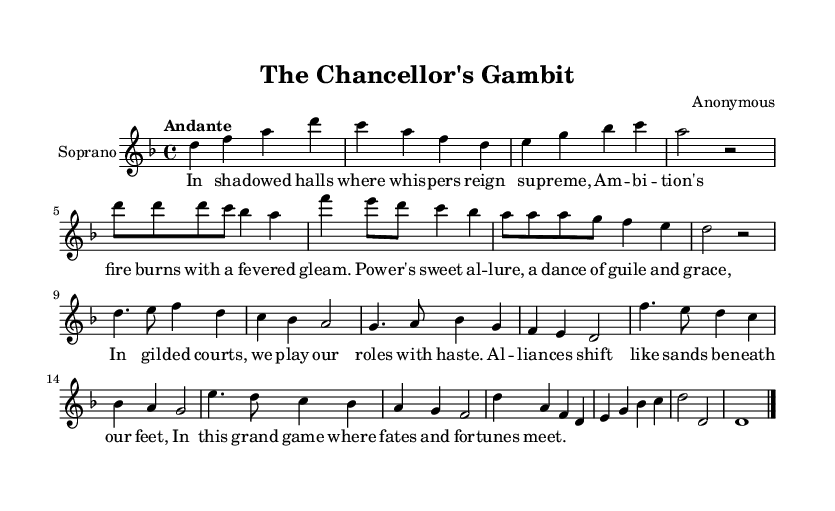What is the key signature of this music? The key signature is D minor, which is indicated by one flat (B flat). This is confirmed by looking at the clef and the beginning of the piece where the key signature is notated.
Answer: D minor What is the time signature of the piece? The time signature is 4/4, which indicates there are four beats in each measure and the quarter note receives one beat. This is shown at the beginning of the score.
Answer: 4/4 What is the tempo marking? The tempo marking is "Andante," which suggests a moderately slow tempo. This is specified in the measure at the beginning of the piece.
Answer: Andante What type of vocal part is featured in this score? The vocal part featured is a Soprano, as indicated by the label on the staff where the music is written.
Answer: Soprano How many measures are in the Aria section? The Aria section consists of 8 measures, which can be counted from the start of the section to its end. The notation clearly delineates this part.
Answer: 8 What musical form is predominantly used in this piece? The predominant form used is the Aria, characterized by its lyrical melody and emotional expression, clearly differentiated from the Recitative segment.
Answer: Aria What literary theme is explored in the lyrics? The lyrics explore themes of power and political intrigue, as indicated by the words describing ambition and the shifting alliances within the context of the music.
Answer: Political intrigue 